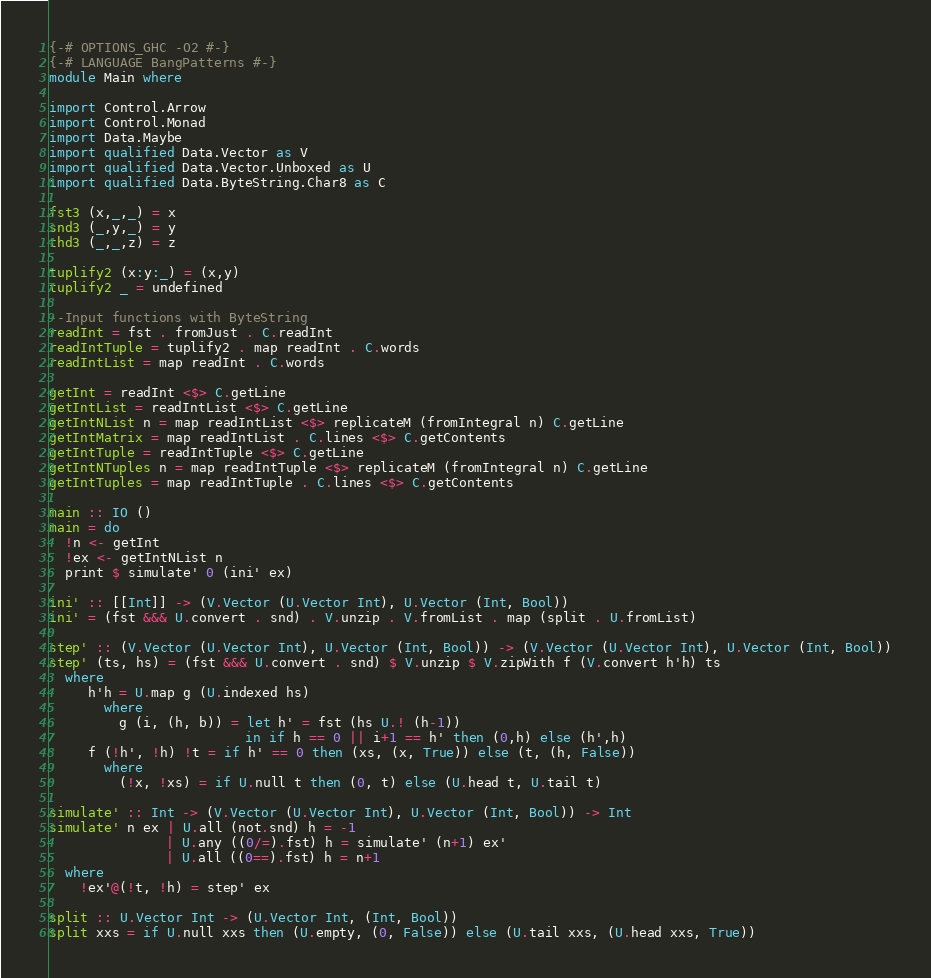<code> <loc_0><loc_0><loc_500><loc_500><_Haskell_>{-# OPTIONS_GHC -O2 #-}
{-# LANGUAGE BangPatterns #-}
module Main where

import Control.Arrow
import Control.Monad
import Data.Maybe
import qualified Data.Vector as V
import qualified Data.Vector.Unboxed as U
import qualified Data.ByteString.Char8 as C

fst3 (x,_,_) = x
snd3 (_,y,_) = y
thd3 (_,_,z) = z

tuplify2 (x:y:_) = (x,y)
tuplify2 _ = undefined

--Input functions with ByteString
readInt = fst . fromJust . C.readInt
readIntTuple = tuplify2 . map readInt . C.words
readIntList = map readInt . C.words

getInt = readInt <$> C.getLine
getIntList = readIntList <$> C.getLine
getIntNList n = map readIntList <$> replicateM (fromIntegral n) C.getLine
getIntMatrix = map readIntList . C.lines <$> C.getContents
getIntTuple = readIntTuple <$> C.getLine
getIntNTuples n = map readIntTuple <$> replicateM (fromIntegral n) C.getLine
getIntTuples = map readIntTuple . C.lines <$> C.getContents

main :: IO ()
main = do
  !n <- getInt
  !ex <- getIntNList n
  print $ simulate' 0 (ini' ex)

ini' :: [[Int]] -> (V.Vector (U.Vector Int), U.Vector (Int, Bool))
ini' = (fst &&& U.convert . snd) . V.unzip . V.fromList . map (split . U.fromList)

step' :: (V.Vector (U.Vector Int), U.Vector (Int, Bool)) -> (V.Vector (U.Vector Int), U.Vector (Int, Bool))
step' (ts, hs) = (fst &&& U.convert . snd) $ V.unzip $ V.zipWith f (V.convert h'h) ts
  where
     h'h = U.map g (U.indexed hs)
       where
         g (i, (h, b)) = let h' = fst (hs U.! (h-1))
                         in if h == 0 || i+1 == h' then (0,h) else (h',h)
     f (!h', !h) !t = if h' == 0 then (xs, (x, True)) else (t, (h, False))
       where
         (!x, !xs) = if U.null t then (0, t) else (U.head t, U.tail t)

simulate' :: Int -> (V.Vector (U.Vector Int), U.Vector (Int, Bool)) -> Int
simulate' n ex | U.all (not.snd) h = -1
               | U.any ((0/=).fst) h = simulate' (n+1) ex'
               | U.all ((0==).fst) h = n+1
  where
    !ex'@(!t, !h) = step' ex

split :: U.Vector Int -> (U.Vector Int, (Int, Bool))
split xxs = if U.null xxs then (U.empty, (0, False)) else (U.tail xxs, (U.head xxs, True))
</code> 